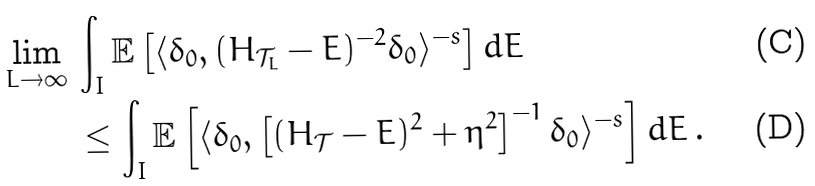Convert formula to latex. <formula><loc_0><loc_0><loc_500><loc_500>\lim _ { L \to \infty } \, & \int _ { I } \mathbb { E } \left [ \langle \delta _ { 0 } , ( H _ { \mathcal { T } _ { L } } - E ) ^ { - 2 } \delta _ { 0 } \rangle ^ { - s } \right ] d E \\ & \leq \int _ { I } \mathbb { E } \left [ \langle \delta _ { 0 } , \left [ ( H _ { \mathcal { T } } - E ) ^ { 2 } + \eta ^ { 2 } \right ] ^ { - 1 } \delta _ { 0 } \rangle ^ { - s } \right ] d E \, .</formula> 